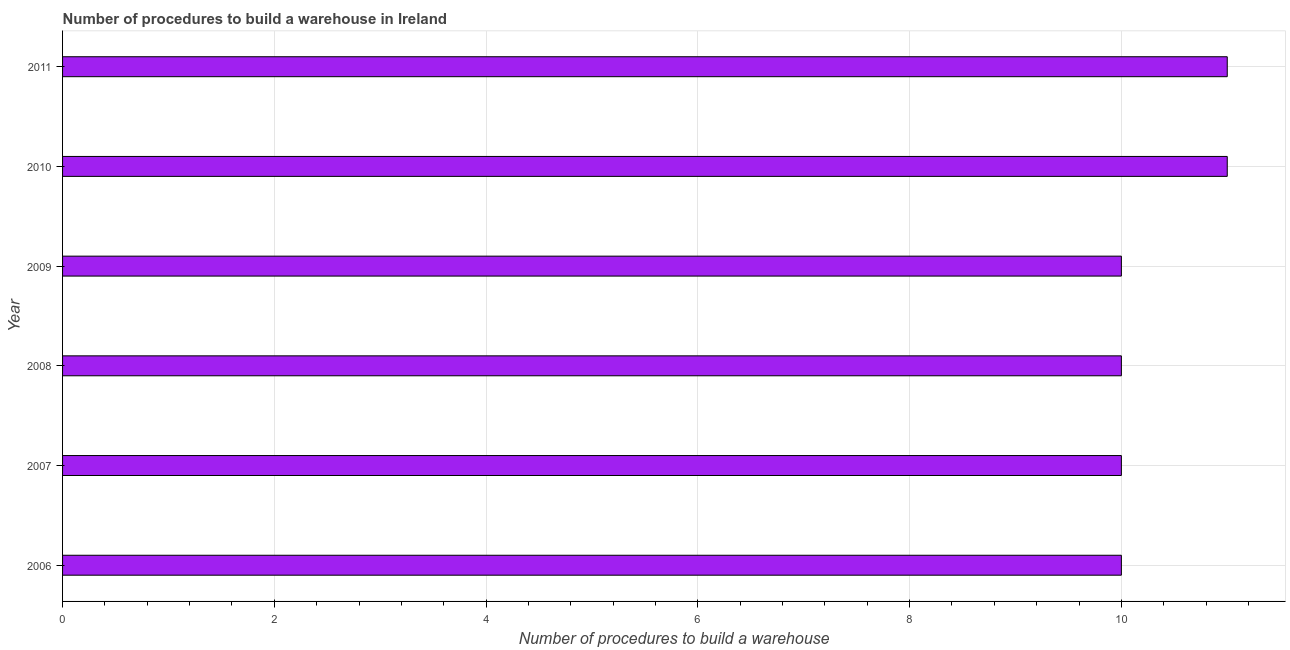Does the graph contain any zero values?
Give a very brief answer. No. What is the title of the graph?
Make the answer very short. Number of procedures to build a warehouse in Ireland. What is the label or title of the X-axis?
Your response must be concise. Number of procedures to build a warehouse. What is the number of procedures to build a warehouse in 2007?
Offer a very short reply. 10. Across all years, what is the minimum number of procedures to build a warehouse?
Give a very brief answer. 10. In which year was the number of procedures to build a warehouse maximum?
Give a very brief answer. 2010. What is the difference between the number of procedures to build a warehouse in 2006 and 2008?
Offer a terse response. 0. What is the median number of procedures to build a warehouse?
Provide a short and direct response. 10. In how many years, is the number of procedures to build a warehouse greater than 6.8 ?
Provide a short and direct response. 6. What is the ratio of the number of procedures to build a warehouse in 2007 to that in 2009?
Offer a terse response. 1. Is the number of procedures to build a warehouse in 2007 less than that in 2009?
Your answer should be compact. No. Is the sum of the number of procedures to build a warehouse in 2007 and 2010 greater than the maximum number of procedures to build a warehouse across all years?
Give a very brief answer. Yes. How many years are there in the graph?
Your answer should be very brief. 6. What is the difference between two consecutive major ticks on the X-axis?
Your answer should be very brief. 2. What is the Number of procedures to build a warehouse of 2006?
Provide a succinct answer. 10. What is the Number of procedures to build a warehouse in 2007?
Provide a succinct answer. 10. What is the Number of procedures to build a warehouse in 2009?
Make the answer very short. 10. What is the Number of procedures to build a warehouse of 2010?
Provide a short and direct response. 11. What is the Number of procedures to build a warehouse in 2011?
Ensure brevity in your answer.  11. What is the difference between the Number of procedures to build a warehouse in 2006 and 2008?
Provide a succinct answer. 0. What is the difference between the Number of procedures to build a warehouse in 2006 and 2009?
Offer a very short reply. 0. What is the difference between the Number of procedures to build a warehouse in 2007 and 2011?
Ensure brevity in your answer.  -1. What is the difference between the Number of procedures to build a warehouse in 2008 and 2009?
Keep it short and to the point. 0. What is the difference between the Number of procedures to build a warehouse in 2008 and 2010?
Provide a short and direct response. -1. What is the difference between the Number of procedures to build a warehouse in 2009 and 2011?
Your answer should be compact. -1. What is the ratio of the Number of procedures to build a warehouse in 2006 to that in 2007?
Provide a succinct answer. 1. What is the ratio of the Number of procedures to build a warehouse in 2006 to that in 2008?
Offer a very short reply. 1. What is the ratio of the Number of procedures to build a warehouse in 2006 to that in 2010?
Ensure brevity in your answer.  0.91. What is the ratio of the Number of procedures to build a warehouse in 2006 to that in 2011?
Provide a short and direct response. 0.91. What is the ratio of the Number of procedures to build a warehouse in 2007 to that in 2008?
Offer a very short reply. 1. What is the ratio of the Number of procedures to build a warehouse in 2007 to that in 2010?
Ensure brevity in your answer.  0.91. What is the ratio of the Number of procedures to build a warehouse in 2007 to that in 2011?
Make the answer very short. 0.91. What is the ratio of the Number of procedures to build a warehouse in 2008 to that in 2010?
Offer a terse response. 0.91. What is the ratio of the Number of procedures to build a warehouse in 2008 to that in 2011?
Your answer should be very brief. 0.91. What is the ratio of the Number of procedures to build a warehouse in 2009 to that in 2010?
Your answer should be compact. 0.91. What is the ratio of the Number of procedures to build a warehouse in 2009 to that in 2011?
Ensure brevity in your answer.  0.91. What is the ratio of the Number of procedures to build a warehouse in 2010 to that in 2011?
Keep it short and to the point. 1. 